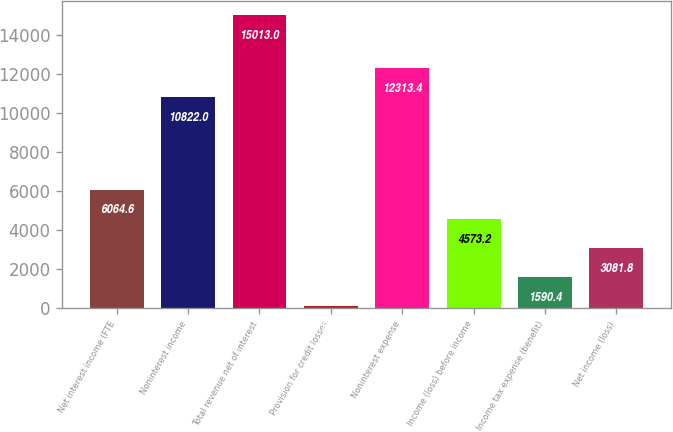<chart> <loc_0><loc_0><loc_500><loc_500><bar_chart><fcel>Net interest income (FTE<fcel>Noninterest income<fcel>Total revenue net of interest<fcel>Provision for credit losses<fcel>Noninterest expense<fcel>Income (loss) before income<fcel>Income tax expense (benefit)<fcel>Net income (loss)<nl><fcel>6064.6<fcel>10822<fcel>15013<fcel>99<fcel>12313.4<fcel>4573.2<fcel>1590.4<fcel>3081.8<nl></chart> 